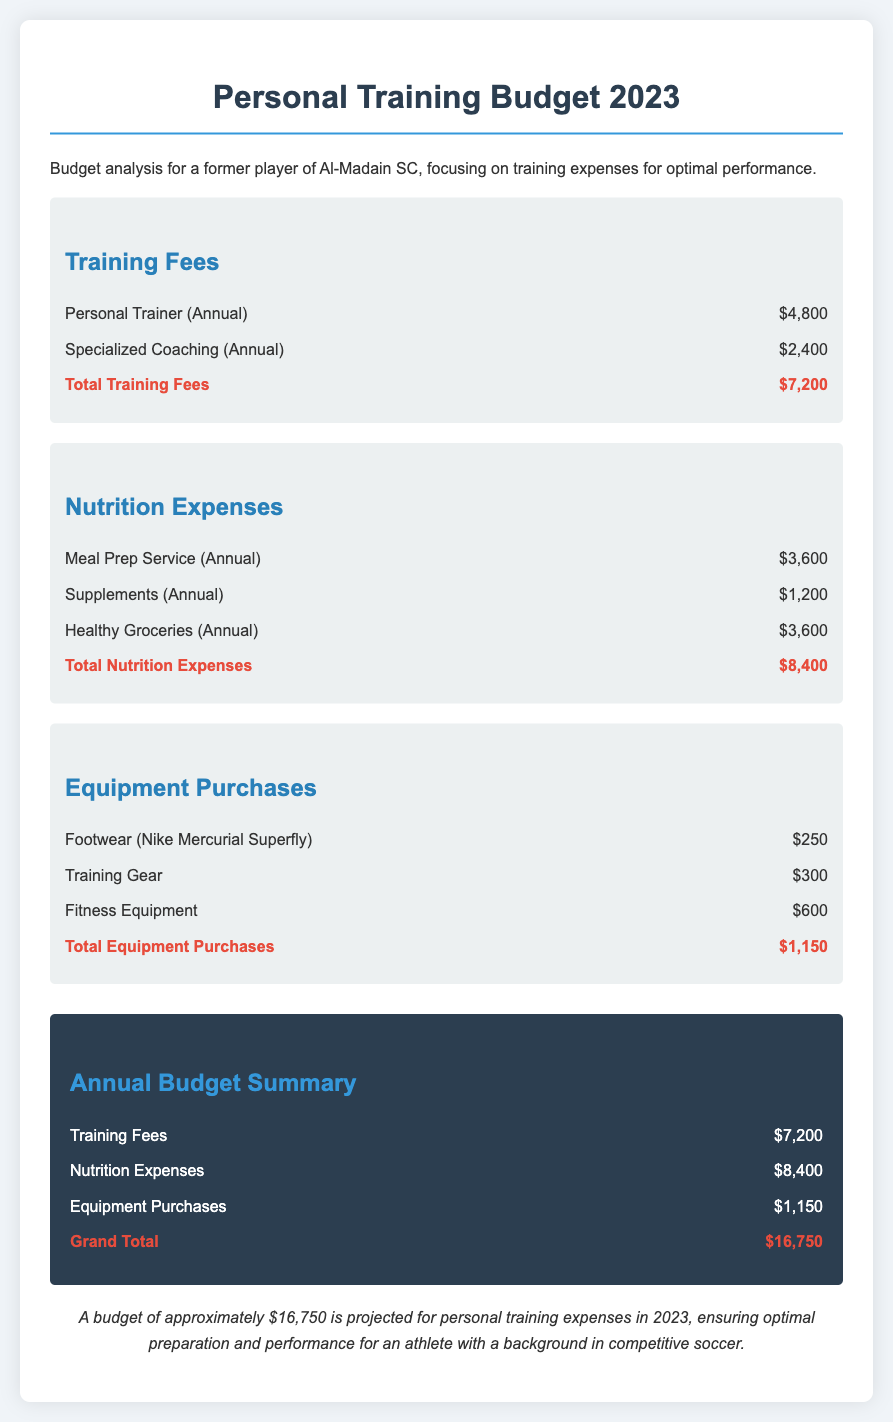What is the total amount allocated for personal training fees? The total training fees consist of Personal Trainer and Specialized Coaching expenses, which add up to $4,800 + $2,400 = $7,200.
Answer: $7,200 How much is spent on meal prep services? The document lists the cost for the Meal Prep Service as $3,600.
Answer: $3,600 What is the total for nutrition expenses? The total nutrition expenses are calculated by adding Meal Prep Service, Supplements, and Healthy Groceries costs, which equals $3,600 + $1,200 + $3,600 = $8,400.
Answer: $8,400 How much was spent on fitness equipment? Fitness Equipment costs $600, as stated in the document.
Answer: $600 What is the grand total for all personal training expenses? The grand total includes Training Fees, Nutrition Expenses, and Equipment Purchases, totaling $7,200 + $8,400 + $1,150 = $16,750.
Answer: $16,750 What type of footwear is included in the equipment purchases? The footwear listed in the document is Nike Mercurial Superfly.
Answer: Nike Mercurial Superfly What is the cost of specialized coaching? The expense for Specialized Coaching is noted as $2,400.
Answer: $2,400 What percentage of the budget is allocated to nutrition expenses? The nutrition expenses total $8,400, which is calculated as a percentage of the grand total $16,750, approximately 50%.
Answer: 50% What is the annual budget projected for personal training expenses? The document states that the projected budget for personal training expenses in 2023 is approximately $16,750.
Answer: $16,750 